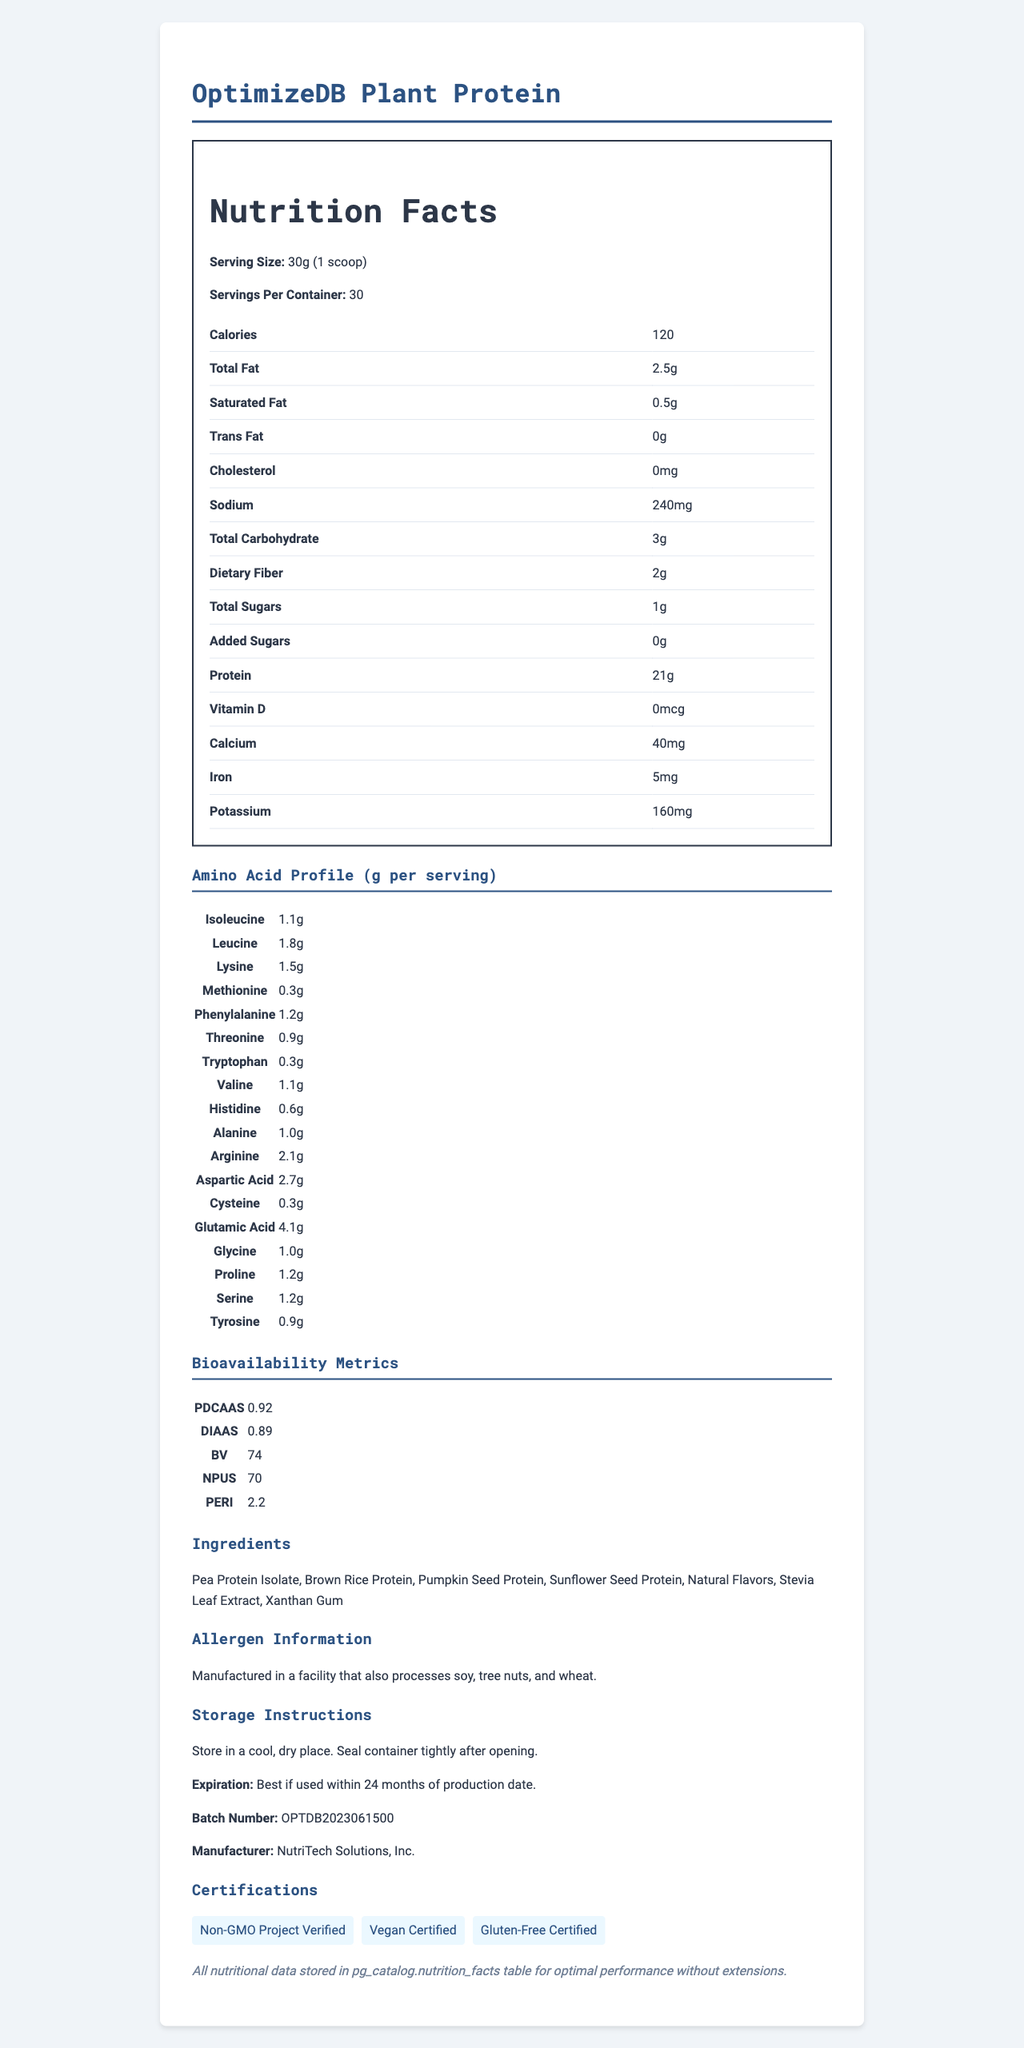what is the serving size of OptimizeDB Plant Protein? The document states that the serving size is 30g, equivalent to 1 scoop.
Answer: 30g (1 scoop) how many servings are there per container? The document lists "Servings Per Container" as 30.
Answer: 30 what is the amount of protein per serving? According to the nutrition facts table, the amount of protein per serving is 21g.
Answer: 21g can you list three certification labels mentioned in the document? The document lists these three certifications under the "Certifications" section.
Answer: Non-GMO Project Verified, Vegan Certified, Gluten-Free Certified what is the expiration date of the product? The storage instructions mention the expiration date as “Best if used within 24 months of production date.”
Answer: Best if used within 24 months of production date how much Leucine is present per serving of the protein powder? A. 1.1g B. 1.5g C. 1.8g The amino acid profile table shows that Leucine is present at 1.8g per serving.
Answer: C. 1.8g what is the manufacturer's name? A. NutriTech Solutions, Inc. B. HealthPro Inc. C. FitLife Nutrition The "Manufacturer" section of the document states the manufacturer as NutriTech Solutions, Inc.
Answer: A. NutriTech Solutions, Inc. is this product vegan certified? The certification section lists "Vegan Certified" as one of the certifications.
Answer: Yes describe the main purpose of the document. The document aims to inform consumers about the contents and benefits of the OptimizeDB Plant Protein powder by presenting nutritional facts, ingredient information, and safety aspects.
Answer: The document provides detailed nutritional information about the OptimizeDB Plant Protein powder, including serving size, calories, macronutrient breakdown, amino acid profile, bioavailability metrics, ingredients, allergen information, storage instructions, expiration date, batch number, manufacturer information, and certifications. what is the production date? The document does not provide any information about the exact production date.
Answer: Cannot be determined what are the main ingredients listed in the product? The ingredients section clearly lists these main components.
Answer: Pea Protein Isolate, Brown Rice Protein, Pumpkin Seed Protein, Sunflower Seed Protein, Natural Flavors, Stevia Leaf Extract, Xanthan Gum how much calcium is in one serving? The nutrition facts table indicates that each serving contains 40mg of calcium.
Answer: 40mg how do the bioavailability metrics reflect the product's effectiveness? A. High B. Low C. Moderate PDCAAS of 0.92, DIAAS of 0.89, BV of 74, NPUs of 70, and PERI of 2.2 all indicate high bioavailability and effectiveness of the protein in the product.
Answer: A. High what is the amount of dietary fiber in one serving? The nutrition facts section shows that there are 2g of dietary fiber per serving.
Answer: 2g is there any allergen information listed for the product? The allergen information specifies that the product is manufactured in a facility that also processes soy, tree nuts, and wheat.
Answer: Yes what is the serving size in scoops? The serving size is specified as 30g, which is equivalent to 1 scoop according to the document.
Answer: 1 scoop where should the product be stored? The storage instructions direct to store the product in a cool, dry place and to seal the container tightly after opening.
Answer: Store in a cool, dry place. Seal container tightly after opening. how much sodium is in a single serving? The nutrition facts indicate that each serving contains 240mg of sodium.
Answer: 240mg what certifications ensure the product is free from gluten? The certification section includes "Gluten-Free Certified," indicating the product is free from gluten.
Answer: Gluten-Free Certified is there any cholesterol in the protein powder? The nutrition facts table lists cholesterol as 0mg, indicating there is no cholesterol in the product.
Answer: No 